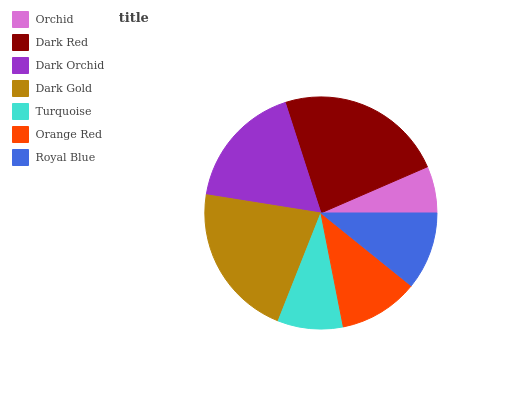Is Orchid the minimum?
Answer yes or no. Yes. Is Dark Red the maximum?
Answer yes or no. Yes. Is Dark Orchid the minimum?
Answer yes or no. No. Is Dark Orchid the maximum?
Answer yes or no. No. Is Dark Red greater than Dark Orchid?
Answer yes or no. Yes. Is Dark Orchid less than Dark Red?
Answer yes or no. Yes. Is Dark Orchid greater than Dark Red?
Answer yes or no. No. Is Dark Red less than Dark Orchid?
Answer yes or no. No. Is Orange Red the high median?
Answer yes or no. Yes. Is Orange Red the low median?
Answer yes or no. Yes. Is Royal Blue the high median?
Answer yes or no. No. Is Royal Blue the low median?
Answer yes or no. No. 